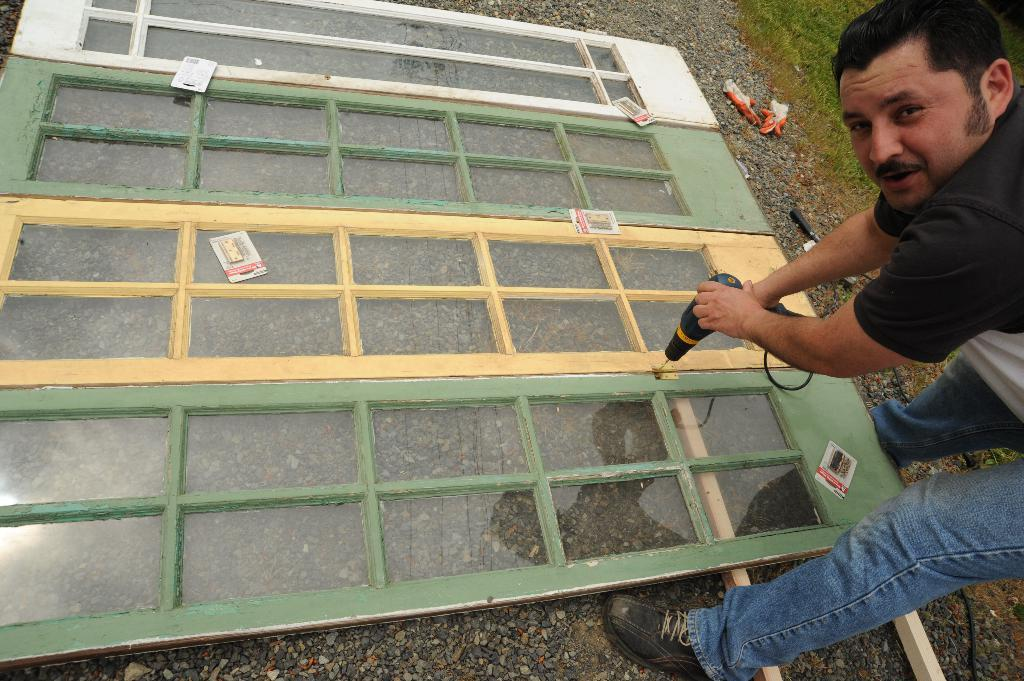What is present in the image? There is a man in the image, and he is wearing clothes and shoes. What is the man holding in his hand? The man is holding an object in his hand. Can you describe the door in the image? There is a wooden door with glass windows in the image. What type of natural environment can be seen in the image? There is sand and grass visible in the image. What type of income does the man in the image have? There is no information about the man's income in the image. What agreement was reached between the man and the object he is holding? There is no indication of any agreement between the man and the object he is holding in the image. 